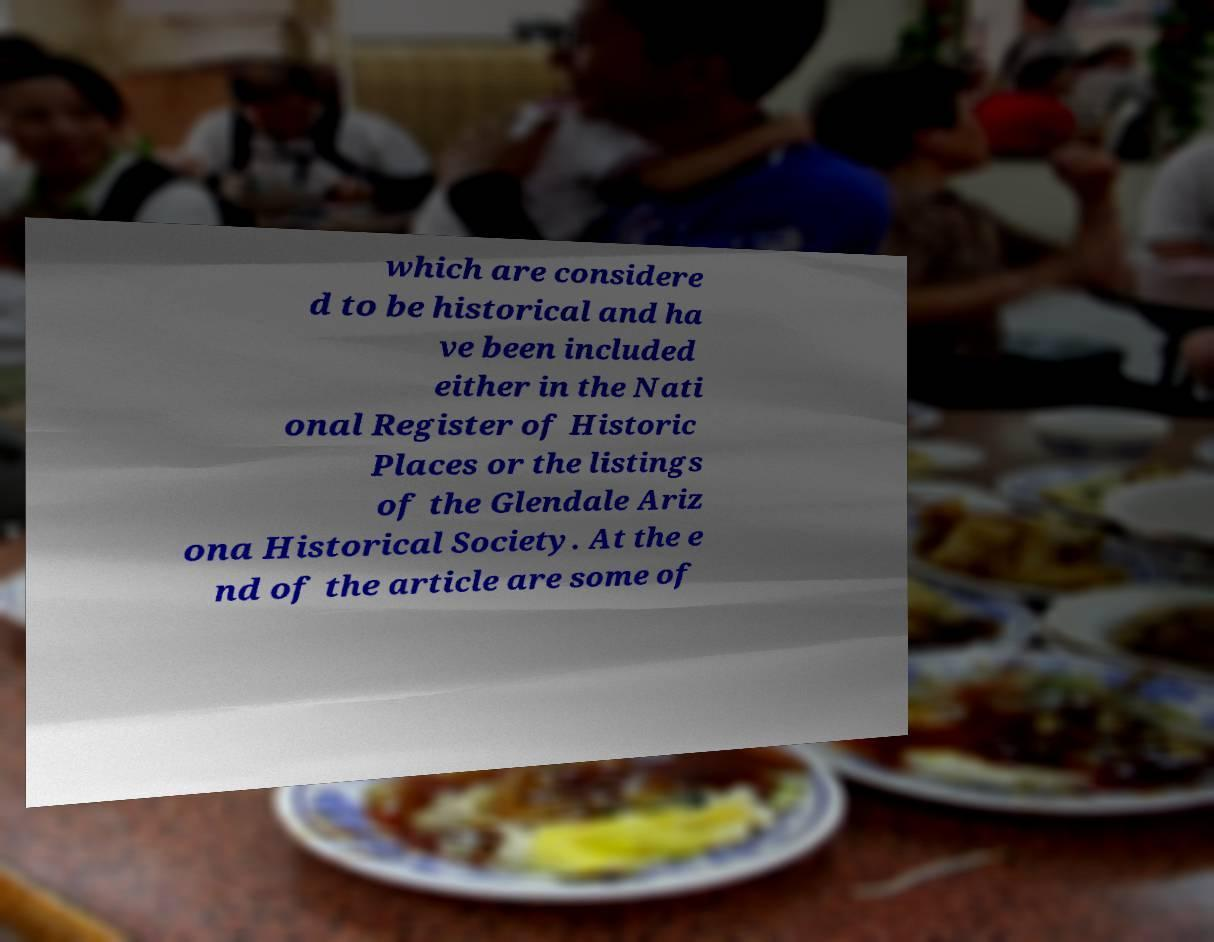I need the written content from this picture converted into text. Can you do that? which are considere d to be historical and ha ve been included either in the Nati onal Register of Historic Places or the listings of the Glendale Ariz ona Historical Society. At the e nd of the article are some of 